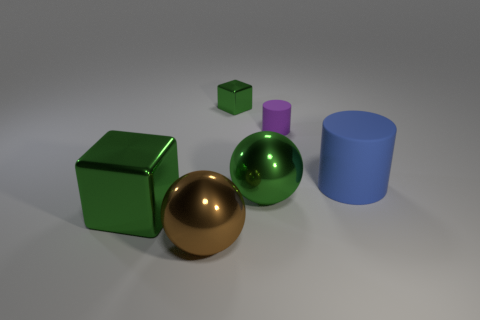Can you describe the lighting and shadows in the scene? Certainly. The scene is illuminated by a diffuse overhead light source, creating soft shadows that fall to the right of the objects. This lighting setup suggests the objects are in a controlled environment, perhaps a studio setup intended to highlight their shapes and materials without harsh glare or overly dramatic shadows. 